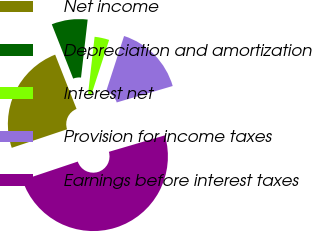Convert chart to OTSL. <chart><loc_0><loc_0><loc_500><loc_500><pie_chart><fcel>Net income<fcel>Depreciation and amortization<fcel>Interest net<fcel>Provision for income taxes<fcel>Earnings before interest taxes<nl><fcel>24.17%<fcel>7.79%<fcel>3.17%<fcel>15.47%<fcel>49.39%<nl></chart> 